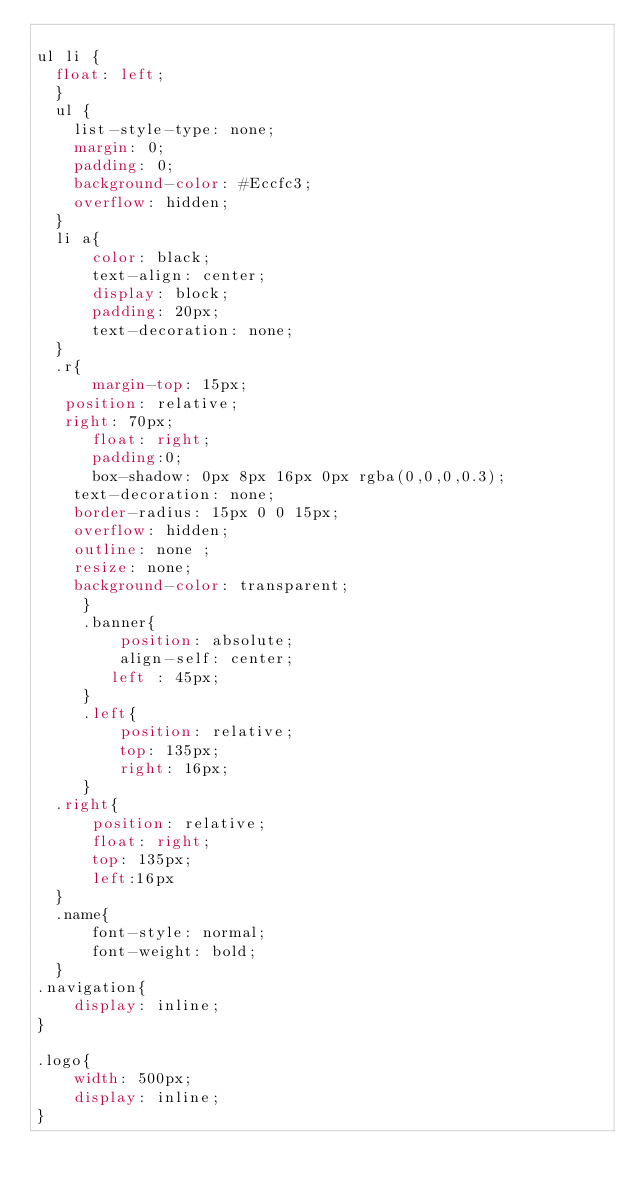<code> <loc_0><loc_0><loc_500><loc_500><_CSS_>
ul li {
  float: left;
  }
  ul {
    list-style-type: none;
    margin: 0;
    padding: 0;
    background-color: #Eccfc3;
    overflow: hidden;
  }
  li a{
      color: black;
      text-align: center;
      display: block;
      padding: 20px;
      text-decoration: none;
  }
  .r{
      margin-top: 15px;
   position: relative;
   right: 70px;
      float: right;
      padding:0;
      box-shadow: 0px 8px 16px 0px rgba(0,0,0,0.3);
    text-decoration: none;
    border-radius: 15px 0 0 15px;
    overflow: hidden;
    outline: none ;
    resize: none;
    background-color: transparent;
     }
     .banner{
         position: absolute;
         align-self: center;
        left : 45px;
     }
     .left{
         position: relative;
         top: 135px;
         right: 16px;
     }
  .right{
      position: relative;
      float: right;
      top: 135px;
      left:16px
  }
  .name{
      font-style: normal;
      font-weight: bold;
  }
.navigation{
    display: inline;
}

.logo{
    width: 500px;
    display: inline;
}</code> 